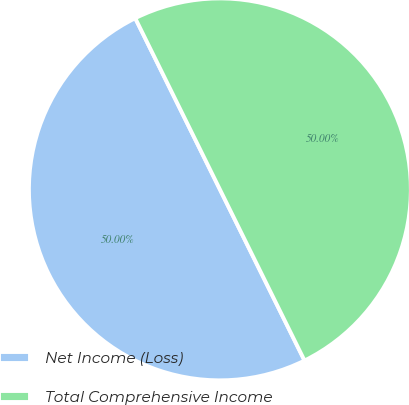Convert chart to OTSL. <chart><loc_0><loc_0><loc_500><loc_500><pie_chart><fcel>Net Income (Loss)<fcel>Total Comprehensive Income<nl><fcel>50.0%<fcel>50.0%<nl></chart> 